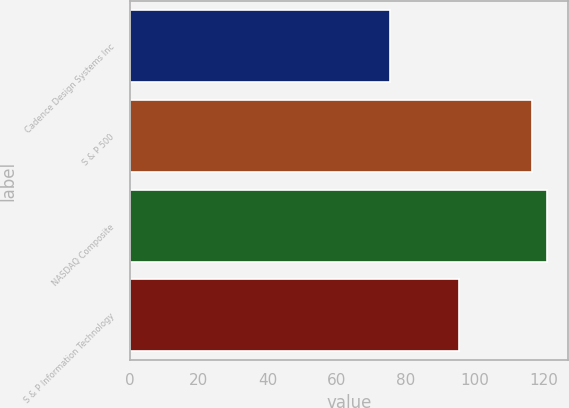Convert chart to OTSL. <chart><loc_0><loc_0><loc_500><loc_500><bar_chart><fcel>Cadence Design Systems Inc<fcel>S & P 500<fcel>NASDAQ Composite<fcel>S & P Information Technology<nl><fcel>75.54<fcel>116.61<fcel>121.11<fcel>95.44<nl></chart> 